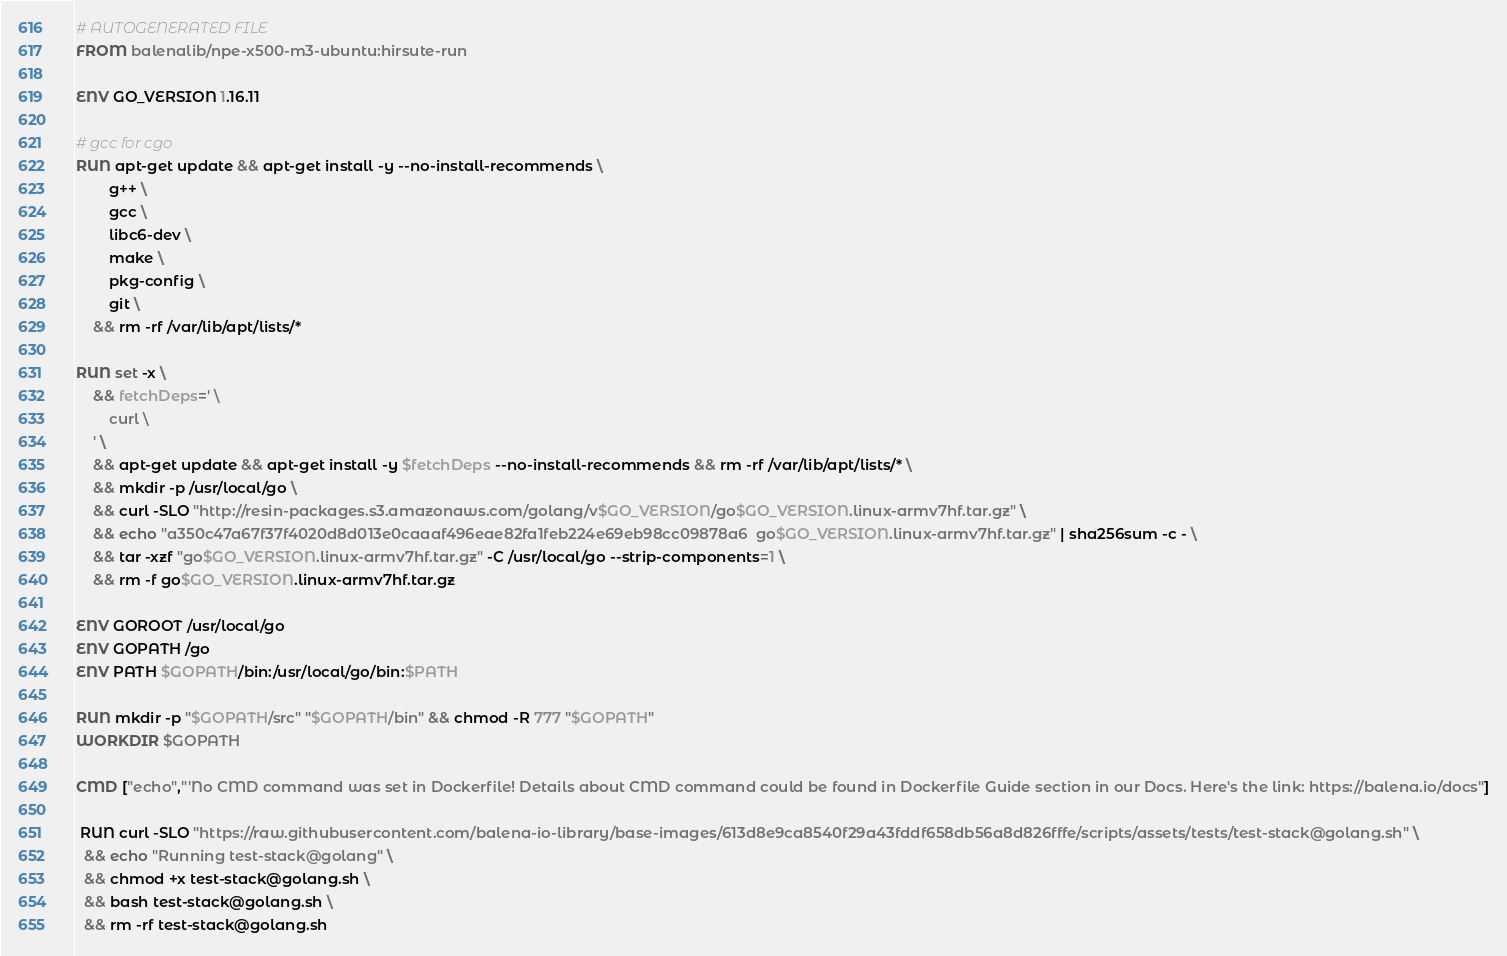Convert code to text. <code><loc_0><loc_0><loc_500><loc_500><_Dockerfile_># AUTOGENERATED FILE
FROM balenalib/npe-x500-m3-ubuntu:hirsute-run

ENV GO_VERSION 1.16.11

# gcc for cgo
RUN apt-get update && apt-get install -y --no-install-recommends \
		g++ \
		gcc \
		libc6-dev \
		make \
		pkg-config \
		git \
	&& rm -rf /var/lib/apt/lists/*

RUN set -x \
	&& fetchDeps=' \
		curl \
	' \
	&& apt-get update && apt-get install -y $fetchDeps --no-install-recommends && rm -rf /var/lib/apt/lists/* \
	&& mkdir -p /usr/local/go \
	&& curl -SLO "http://resin-packages.s3.amazonaws.com/golang/v$GO_VERSION/go$GO_VERSION.linux-armv7hf.tar.gz" \
	&& echo "a350c47a67f37f4020d8d013e0caaaf496eae82fa1feb224e69eb98cc09878a6  go$GO_VERSION.linux-armv7hf.tar.gz" | sha256sum -c - \
	&& tar -xzf "go$GO_VERSION.linux-armv7hf.tar.gz" -C /usr/local/go --strip-components=1 \
	&& rm -f go$GO_VERSION.linux-armv7hf.tar.gz

ENV GOROOT /usr/local/go
ENV GOPATH /go
ENV PATH $GOPATH/bin:/usr/local/go/bin:$PATH

RUN mkdir -p "$GOPATH/src" "$GOPATH/bin" && chmod -R 777 "$GOPATH"
WORKDIR $GOPATH

CMD ["echo","'No CMD command was set in Dockerfile! Details about CMD command could be found in Dockerfile Guide section in our Docs. Here's the link: https://balena.io/docs"]

 RUN curl -SLO "https://raw.githubusercontent.com/balena-io-library/base-images/613d8e9ca8540f29a43fddf658db56a8d826fffe/scripts/assets/tests/test-stack@golang.sh" \
  && echo "Running test-stack@golang" \
  && chmod +x test-stack@golang.sh \
  && bash test-stack@golang.sh \
  && rm -rf test-stack@golang.sh 
</code> 